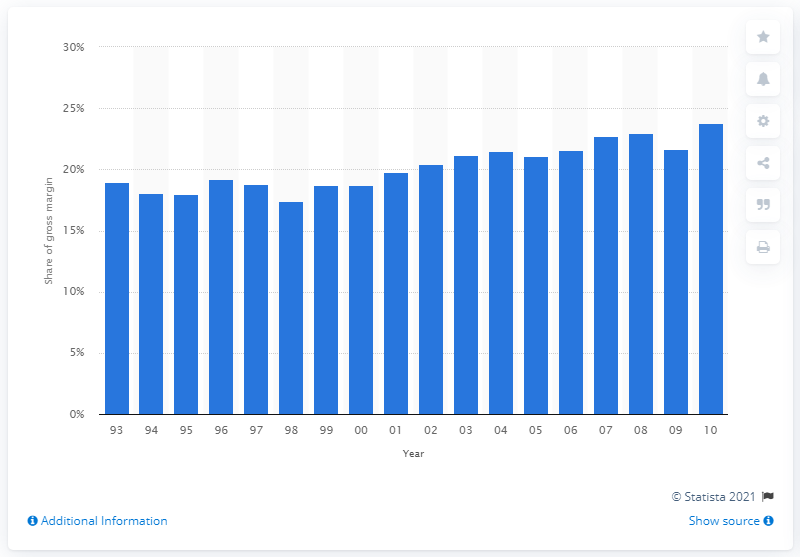Give some essential details in this illustration. In 2010, the gross margin for lumber and other construction materials was 23.8%. 